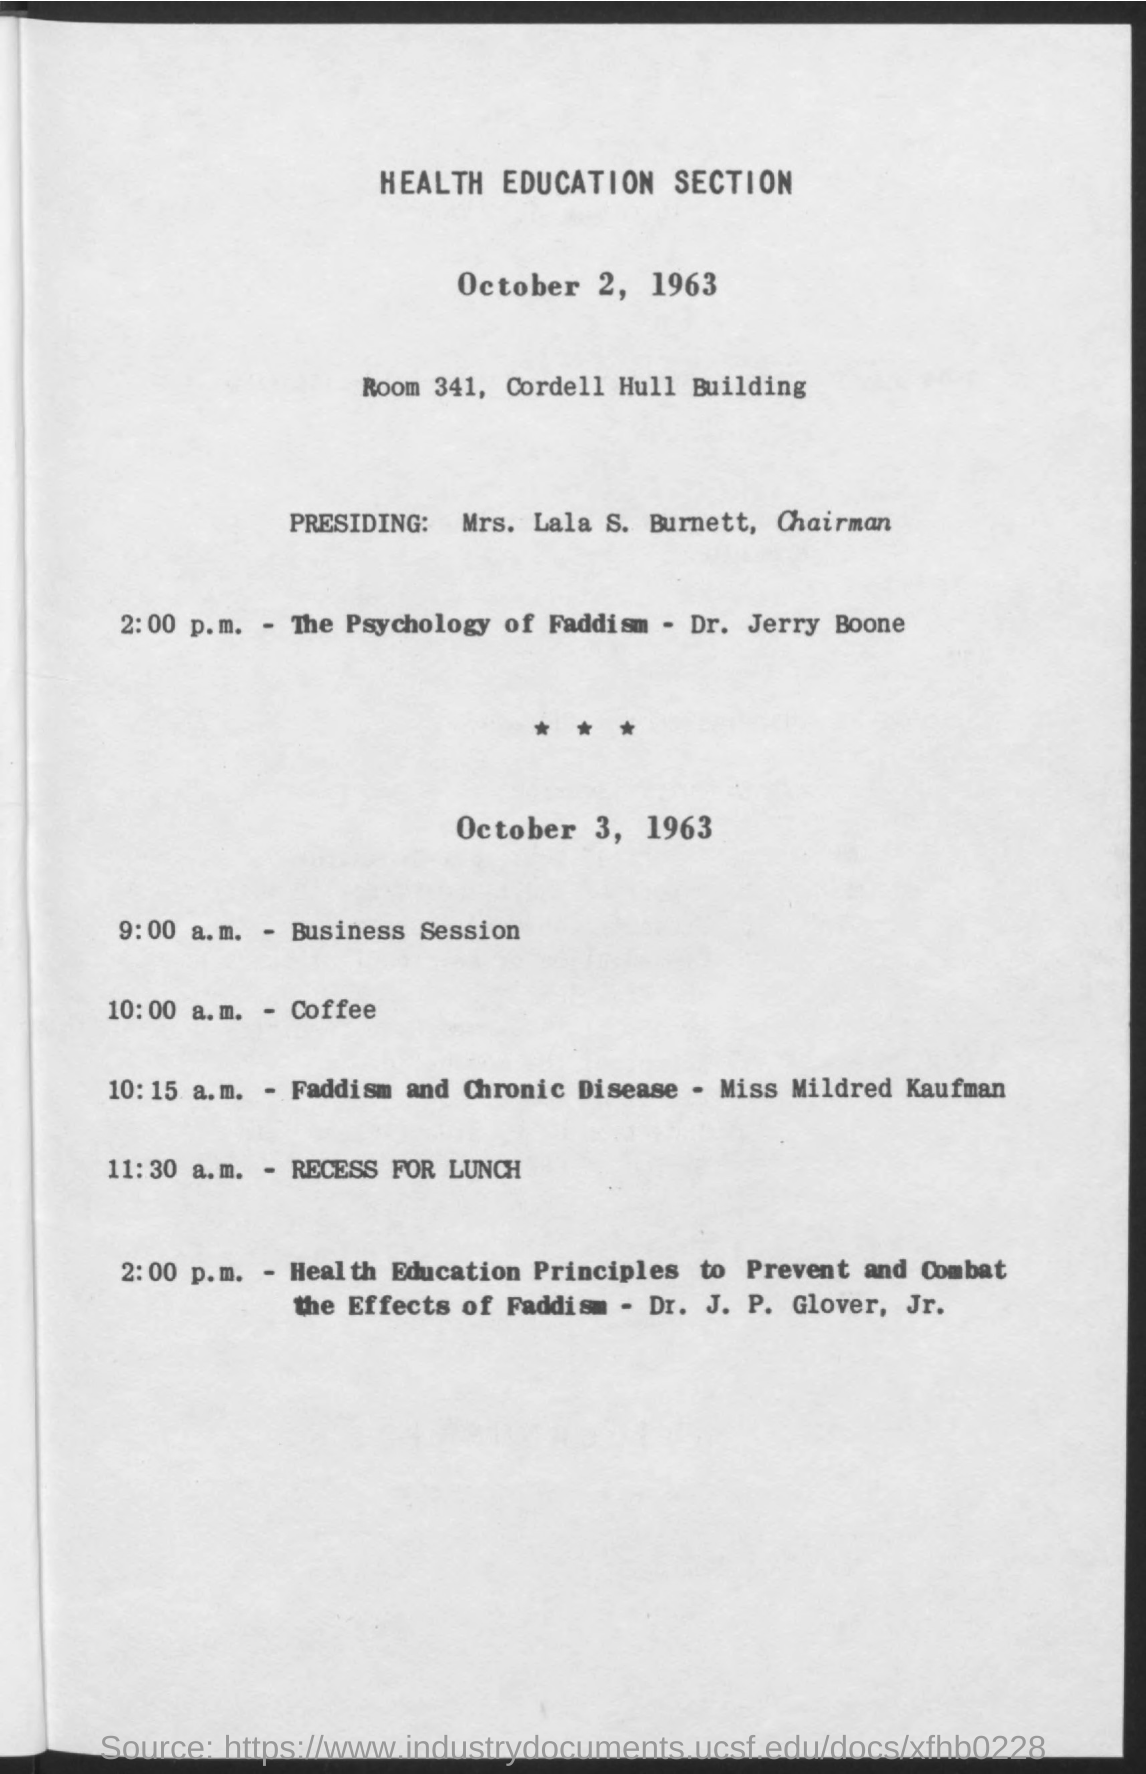Identify some key points in this picture. The Chairman is presiding over it. The time for coffee is 10:00 a.M. The event will take place in ROOM 341 of the Cordell Hull Building. 